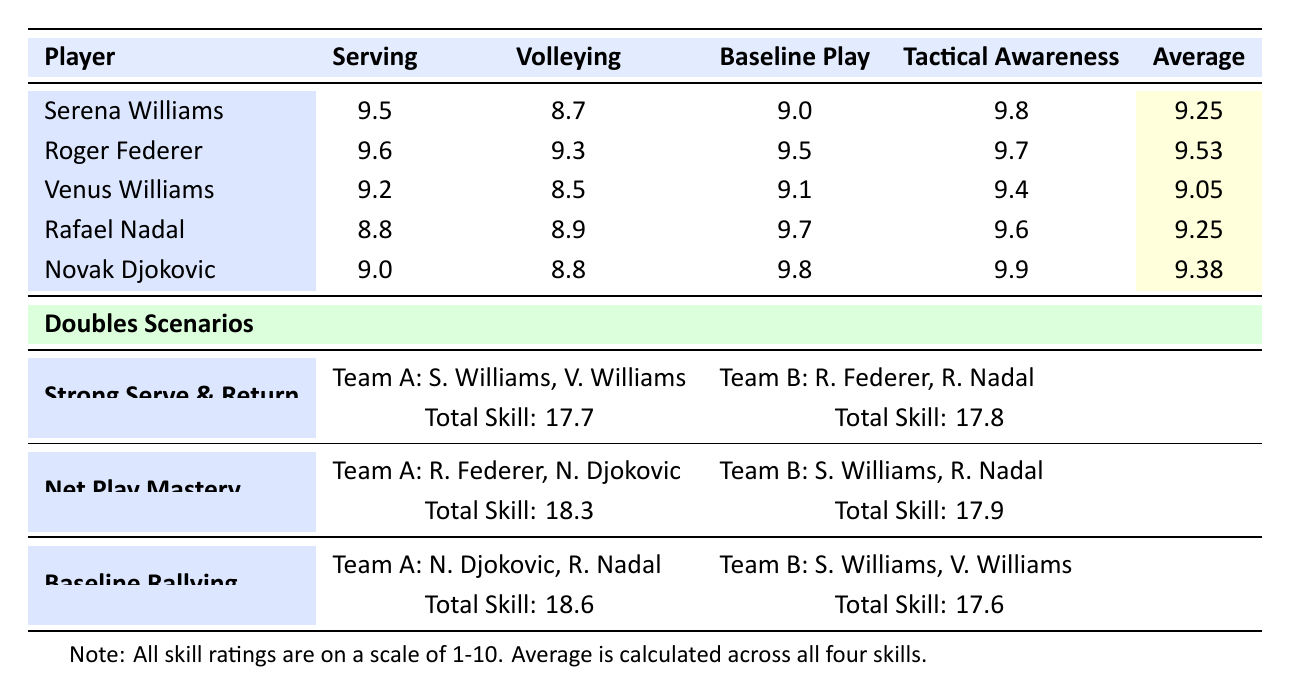What is the highest skill rating for serving? The serving skill ratings are listed in the table, and the highest rating is for Roger Federer at 9.6.
Answer: 9.6 What team had the highest total skill rating in the "Strong Serve & Return" scenario? Team B, which consists of Roger Federer and Rafael Nadal, scored a total skill rating of 17.8, compared to Team A's 17.7.
Answer: Team B What is the average tactical awareness score for all players? The tactical awareness scores are 9.8, 9.7, 9.4, 9.6, and 9.9. Adding these gives 48.4; dividing by 5 gives an average of 9.68.
Answer: 9.68 Which player has the lowest volleying skill rating? The volleying skill ratings indicated in the table show that Venus Williams has the lowest rating at 8.5.
Answer: 8.5 True or false: Novak Djokovic has a higher average skill rating than Serena Williams. Novak Djokovic’s average is 9.38, while Serena Williams’ average is 9.25. Therefore, the statement is true.
Answer: True What is the combined total skill rating for Team A in the "Baseline Rallying" scenario? Team A in that scenario consists of Novak Djokovic and Rafael Nadal. Their individual skill ratings are combined, giving a total of 9.0 + 8.8 + 9.8 + 9.6 = 18.6.
Answer: 18.6 Which team performed better in net play mastery, and by how much? Team A, consisting of Roger Federer and Novak Djokovic, scored 18.3, while Team B (Serena Williams and Rafael Nadal) scored 17.9. The difference is 18.3 - 17.9 = 0.4.
Answer: Team A, by 0.4 How do Serena Williams' serving and baseline play scores compare? Serena Williams has a serving score of 9.5 and a baseline play score of 9.0. The difference is 9.5 - 9.0 = 0.5. Her serving score is higher.
Answer: 0.5 What was the total skill score for Team B in the "Strong Serve & Return" scenario? In the "Strong Serve & Return" scenario, Team B, which includes Roger Federer and Rafael Nadal, has a total skill rating of 17.8, as directly stated in the table.
Answer: 17.8 